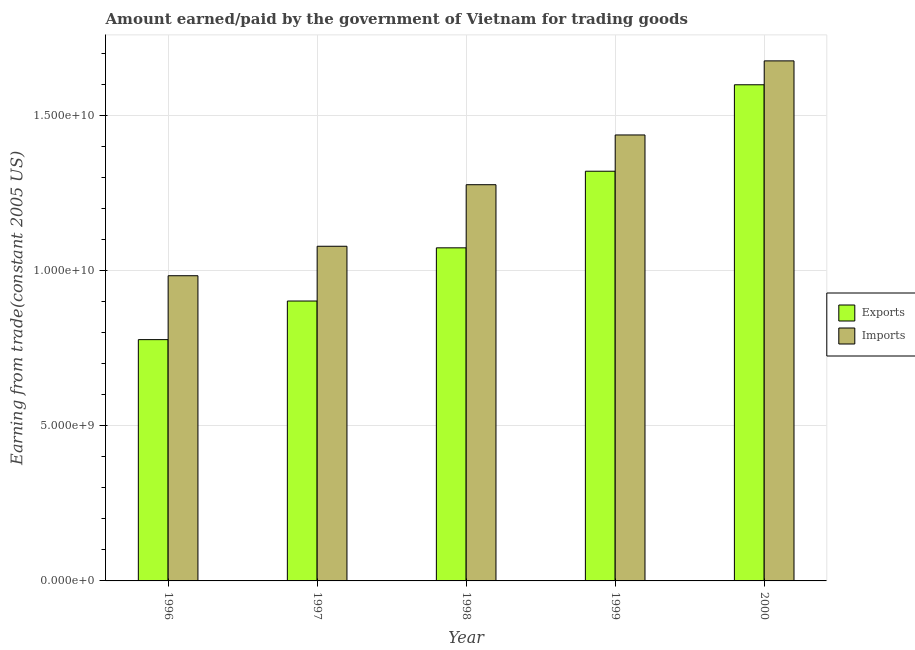How many different coloured bars are there?
Offer a very short reply. 2. How many groups of bars are there?
Ensure brevity in your answer.  5. How many bars are there on the 5th tick from the left?
Keep it short and to the point. 2. What is the amount paid for imports in 1996?
Provide a short and direct response. 9.84e+09. Across all years, what is the maximum amount earned from exports?
Your response must be concise. 1.60e+1. Across all years, what is the minimum amount earned from exports?
Your response must be concise. 7.78e+09. In which year was the amount earned from exports maximum?
Your answer should be compact. 2000. What is the total amount earned from exports in the graph?
Provide a short and direct response. 5.67e+1. What is the difference between the amount paid for imports in 1998 and that in 1999?
Your response must be concise. -1.60e+09. What is the difference between the amount earned from exports in 1997 and the amount paid for imports in 1998?
Offer a very short reply. -1.71e+09. What is the average amount paid for imports per year?
Give a very brief answer. 1.29e+1. In the year 1999, what is the difference between the amount paid for imports and amount earned from exports?
Provide a short and direct response. 0. What is the ratio of the amount earned from exports in 1999 to that in 2000?
Your answer should be compact. 0.83. What is the difference between the highest and the second highest amount earned from exports?
Make the answer very short. 2.79e+09. What is the difference between the highest and the lowest amount paid for imports?
Offer a terse response. 6.93e+09. In how many years, is the amount paid for imports greater than the average amount paid for imports taken over all years?
Provide a short and direct response. 2. Is the sum of the amount earned from exports in 1998 and 2000 greater than the maximum amount paid for imports across all years?
Give a very brief answer. Yes. What does the 1st bar from the left in 1996 represents?
Offer a very short reply. Exports. What does the 2nd bar from the right in 2000 represents?
Your answer should be compact. Exports. How many bars are there?
Your answer should be very brief. 10. Are all the bars in the graph horizontal?
Your answer should be very brief. No. How many years are there in the graph?
Offer a terse response. 5. What is the difference between two consecutive major ticks on the Y-axis?
Make the answer very short. 5.00e+09. Does the graph contain any zero values?
Ensure brevity in your answer.  No. Does the graph contain grids?
Provide a succinct answer. Yes. Where does the legend appear in the graph?
Keep it short and to the point. Center right. How many legend labels are there?
Keep it short and to the point. 2. What is the title of the graph?
Give a very brief answer. Amount earned/paid by the government of Vietnam for trading goods. Does "Gasoline" appear as one of the legend labels in the graph?
Offer a terse response. No. What is the label or title of the Y-axis?
Your answer should be compact. Earning from trade(constant 2005 US). What is the Earning from trade(constant 2005 US) of Exports in 1996?
Give a very brief answer. 7.78e+09. What is the Earning from trade(constant 2005 US) in Imports in 1996?
Your response must be concise. 9.84e+09. What is the Earning from trade(constant 2005 US) of Exports in 1997?
Make the answer very short. 9.02e+09. What is the Earning from trade(constant 2005 US) in Imports in 1997?
Your answer should be compact. 1.08e+1. What is the Earning from trade(constant 2005 US) in Exports in 1998?
Your answer should be very brief. 1.07e+1. What is the Earning from trade(constant 2005 US) of Imports in 1998?
Your answer should be very brief. 1.28e+1. What is the Earning from trade(constant 2005 US) of Exports in 1999?
Your answer should be compact. 1.32e+1. What is the Earning from trade(constant 2005 US) in Imports in 1999?
Your response must be concise. 1.44e+1. What is the Earning from trade(constant 2005 US) in Exports in 2000?
Your answer should be very brief. 1.60e+1. What is the Earning from trade(constant 2005 US) in Imports in 2000?
Provide a short and direct response. 1.68e+1. Across all years, what is the maximum Earning from trade(constant 2005 US) of Exports?
Provide a succinct answer. 1.60e+1. Across all years, what is the maximum Earning from trade(constant 2005 US) of Imports?
Your answer should be compact. 1.68e+1. Across all years, what is the minimum Earning from trade(constant 2005 US) of Exports?
Provide a succinct answer. 7.78e+09. Across all years, what is the minimum Earning from trade(constant 2005 US) in Imports?
Your response must be concise. 9.84e+09. What is the total Earning from trade(constant 2005 US) of Exports in the graph?
Make the answer very short. 5.67e+1. What is the total Earning from trade(constant 2005 US) of Imports in the graph?
Offer a very short reply. 6.45e+1. What is the difference between the Earning from trade(constant 2005 US) in Exports in 1996 and that in 1997?
Make the answer very short. -1.24e+09. What is the difference between the Earning from trade(constant 2005 US) in Imports in 1996 and that in 1997?
Provide a short and direct response. -9.50e+08. What is the difference between the Earning from trade(constant 2005 US) of Exports in 1996 and that in 1998?
Offer a terse response. -2.96e+09. What is the difference between the Earning from trade(constant 2005 US) of Imports in 1996 and that in 1998?
Give a very brief answer. -2.93e+09. What is the difference between the Earning from trade(constant 2005 US) of Exports in 1996 and that in 1999?
Your response must be concise. -5.43e+09. What is the difference between the Earning from trade(constant 2005 US) in Imports in 1996 and that in 1999?
Provide a succinct answer. -4.54e+09. What is the difference between the Earning from trade(constant 2005 US) in Exports in 1996 and that in 2000?
Your answer should be compact. -8.22e+09. What is the difference between the Earning from trade(constant 2005 US) in Imports in 1996 and that in 2000?
Provide a succinct answer. -6.93e+09. What is the difference between the Earning from trade(constant 2005 US) of Exports in 1997 and that in 1998?
Provide a short and direct response. -1.71e+09. What is the difference between the Earning from trade(constant 2005 US) of Imports in 1997 and that in 1998?
Your answer should be compact. -1.98e+09. What is the difference between the Earning from trade(constant 2005 US) of Exports in 1997 and that in 1999?
Make the answer very short. -4.18e+09. What is the difference between the Earning from trade(constant 2005 US) in Imports in 1997 and that in 1999?
Your answer should be very brief. -3.59e+09. What is the difference between the Earning from trade(constant 2005 US) of Exports in 1997 and that in 2000?
Your response must be concise. -6.97e+09. What is the difference between the Earning from trade(constant 2005 US) in Imports in 1997 and that in 2000?
Keep it short and to the point. -5.98e+09. What is the difference between the Earning from trade(constant 2005 US) in Exports in 1998 and that in 1999?
Give a very brief answer. -2.47e+09. What is the difference between the Earning from trade(constant 2005 US) in Imports in 1998 and that in 1999?
Offer a very short reply. -1.60e+09. What is the difference between the Earning from trade(constant 2005 US) of Exports in 1998 and that in 2000?
Offer a terse response. -5.26e+09. What is the difference between the Earning from trade(constant 2005 US) in Imports in 1998 and that in 2000?
Your answer should be very brief. -3.99e+09. What is the difference between the Earning from trade(constant 2005 US) in Exports in 1999 and that in 2000?
Your response must be concise. -2.79e+09. What is the difference between the Earning from trade(constant 2005 US) in Imports in 1999 and that in 2000?
Offer a terse response. -2.39e+09. What is the difference between the Earning from trade(constant 2005 US) in Exports in 1996 and the Earning from trade(constant 2005 US) in Imports in 1997?
Your answer should be very brief. -3.01e+09. What is the difference between the Earning from trade(constant 2005 US) in Exports in 1996 and the Earning from trade(constant 2005 US) in Imports in 1998?
Make the answer very short. -4.99e+09. What is the difference between the Earning from trade(constant 2005 US) in Exports in 1996 and the Earning from trade(constant 2005 US) in Imports in 1999?
Offer a terse response. -6.60e+09. What is the difference between the Earning from trade(constant 2005 US) in Exports in 1996 and the Earning from trade(constant 2005 US) in Imports in 2000?
Your response must be concise. -8.99e+09. What is the difference between the Earning from trade(constant 2005 US) in Exports in 1997 and the Earning from trade(constant 2005 US) in Imports in 1998?
Offer a terse response. -3.75e+09. What is the difference between the Earning from trade(constant 2005 US) in Exports in 1997 and the Earning from trade(constant 2005 US) in Imports in 1999?
Keep it short and to the point. -5.35e+09. What is the difference between the Earning from trade(constant 2005 US) of Exports in 1997 and the Earning from trade(constant 2005 US) of Imports in 2000?
Offer a terse response. -7.74e+09. What is the difference between the Earning from trade(constant 2005 US) in Exports in 1998 and the Earning from trade(constant 2005 US) in Imports in 1999?
Your response must be concise. -3.64e+09. What is the difference between the Earning from trade(constant 2005 US) in Exports in 1998 and the Earning from trade(constant 2005 US) in Imports in 2000?
Keep it short and to the point. -6.03e+09. What is the difference between the Earning from trade(constant 2005 US) in Exports in 1999 and the Earning from trade(constant 2005 US) in Imports in 2000?
Your answer should be compact. -3.56e+09. What is the average Earning from trade(constant 2005 US) in Exports per year?
Give a very brief answer. 1.13e+1. What is the average Earning from trade(constant 2005 US) of Imports per year?
Ensure brevity in your answer.  1.29e+1. In the year 1996, what is the difference between the Earning from trade(constant 2005 US) of Exports and Earning from trade(constant 2005 US) of Imports?
Ensure brevity in your answer.  -2.06e+09. In the year 1997, what is the difference between the Earning from trade(constant 2005 US) of Exports and Earning from trade(constant 2005 US) of Imports?
Offer a terse response. -1.77e+09. In the year 1998, what is the difference between the Earning from trade(constant 2005 US) in Exports and Earning from trade(constant 2005 US) in Imports?
Offer a terse response. -2.04e+09. In the year 1999, what is the difference between the Earning from trade(constant 2005 US) in Exports and Earning from trade(constant 2005 US) in Imports?
Keep it short and to the point. -1.17e+09. In the year 2000, what is the difference between the Earning from trade(constant 2005 US) of Exports and Earning from trade(constant 2005 US) of Imports?
Provide a short and direct response. -7.71e+08. What is the ratio of the Earning from trade(constant 2005 US) of Exports in 1996 to that in 1997?
Keep it short and to the point. 0.86. What is the ratio of the Earning from trade(constant 2005 US) of Imports in 1996 to that in 1997?
Your answer should be very brief. 0.91. What is the ratio of the Earning from trade(constant 2005 US) of Exports in 1996 to that in 1998?
Your answer should be very brief. 0.72. What is the ratio of the Earning from trade(constant 2005 US) of Imports in 1996 to that in 1998?
Provide a short and direct response. 0.77. What is the ratio of the Earning from trade(constant 2005 US) in Exports in 1996 to that in 1999?
Provide a short and direct response. 0.59. What is the ratio of the Earning from trade(constant 2005 US) of Imports in 1996 to that in 1999?
Keep it short and to the point. 0.68. What is the ratio of the Earning from trade(constant 2005 US) of Exports in 1996 to that in 2000?
Ensure brevity in your answer.  0.49. What is the ratio of the Earning from trade(constant 2005 US) in Imports in 1996 to that in 2000?
Offer a terse response. 0.59. What is the ratio of the Earning from trade(constant 2005 US) of Exports in 1997 to that in 1998?
Make the answer very short. 0.84. What is the ratio of the Earning from trade(constant 2005 US) of Imports in 1997 to that in 1998?
Your response must be concise. 0.84. What is the ratio of the Earning from trade(constant 2005 US) of Exports in 1997 to that in 1999?
Your answer should be very brief. 0.68. What is the ratio of the Earning from trade(constant 2005 US) in Imports in 1997 to that in 1999?
Keep it short and to the point. 0.75. What is the ratio of the Earning from trade(constant 2005 US) of Exports in 1997 to that in 2000?
Your response must be concise. 0.56. What is the ratio of the Earning from trade(constant 2005 US) of Imports in 1997 to that in 2000?
Ensure brevity in your answer.  0.64. What is the ratio of the Earning from trade(constant 2005 US) of Exports in 1998 to that in 1999?
Ensure brevity in your answer.  0.81. What is the ratio of the Earning from trade(constant 2005 US) of Imports in 1998 to that in 1999?
Your answer should be compact. 0.89. What is the ratio of the Earning from trade(constant 2005 US) of Exports in 1998 to that in 2000?
Your answer should be very brief. 0.67. What is the ratio of the Earning from trade(constant 2005 US) of Imports in 1998 to that in 2000?
Your answer should be compact. 0.76. What is the ratio of the Earning from trade(constant 2005 US) in Exports in 1999 to that in 2000?
Ensure brevity in your answer.  0.83. What is the ratio of the Earning from trade(constant 2005 US) of Imports in 1999 to that in 2000?
Your response must be concise. 0.86. What is the difference between the highest and the second highest Earning from trade(constant 2005 US) in Exports?
Your answer should be compact. 2.79e+09. What is the difference between the highest and the second highest Earning from trade(constant 2005 US) of Imports?
Provide a succinct answer. 2.39e+09. What is the difference between the highest and the lowest Earning from trade(constant 2005 US) in Exports?
Offer a terse response. 8.22e+09. What is the difference between the highest and the lowest Earning from trade(constant 2005 US) of Imports?
Offer a terse response. 6.93e+09. 